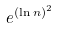<formula> <loc_0><loc_0><loc_500><loc_500>e ^ { ( \ln n ) ^ { 2 } }</formula> 